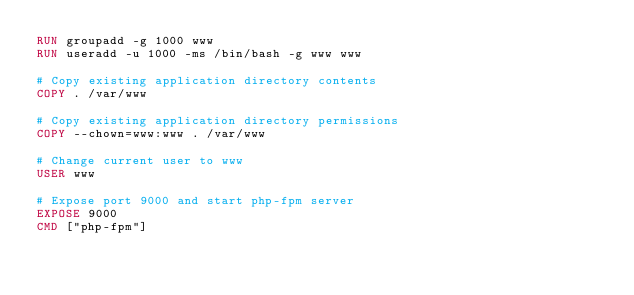Convert code to text. <code><loc_0><loc_0><loc_500><loc_500><_Dockerfile_>RUN groupadd -g 1000 www
RUN useradd -u 1000 -ms /bin/bash -g www www

# Copy existing application directory contents
COPY . /var/www

# Copy existing application directory permissions
COPY --chown=www:www . /var/www

# Change current user to www
USER www

# Expose port 9000 and start php-fpm server
EXPOSE 9000
CMD ["php-fpm"]
</code> 